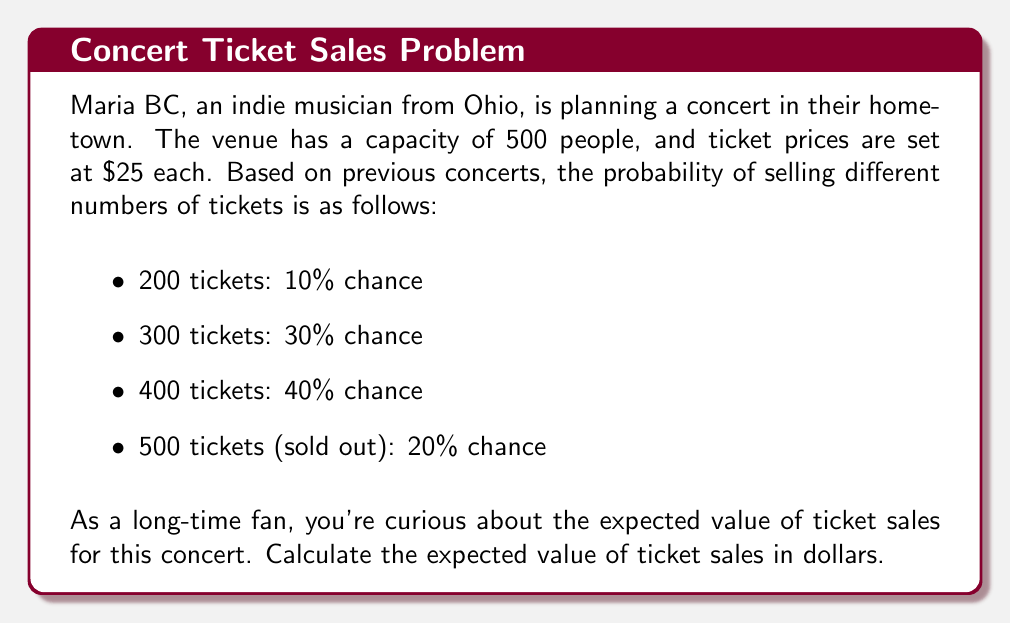Teach me how to tackle this problem. To calculate the expected value of ticket sales, we need to follow these steps:

1. Identify the possible outcomes and their probabilities:
   - 200 tickets: $P(200) = 0.10$
   - 300 tickets: $P(300) = 0.30$
   - 400 tickets: $P(400) = 0.40$
   - 500 tickets: $P(500) = 0.20$

2. Calculate the ticket sales for each outcome:
   - 200 tickets: $200 \times $25 = $5,000$
   - 300 tickets: $300 \times $25 = $7,500$
   - 400 tickets: $400 \times $25 = $10,000$
   - 500 tickets: $500 \times $25 = $12,500$

3. Apply the expected value formula:
   $$E(X) = \sum_{i=1}^{n} x_i \cdot P(x_i)$$
   Where $x_i$ is the ticket sales amount and $P(x_i)$ is the probability of that outcome.

4. Substitute the values:
   $$E(X) = 5000 \cdot 0.10 + 7500 \cdot 0.30 + 10000 \cdot 0.40 + 12500 \cdot 0.20$$

5. Calculate:
   $$E(X) = 500 + 2250 + 4000 + 2500 = 9250$$

Therefore, the expected value of ticket sales for the Maria BC concert is $9,250.
Answer: $9,250 